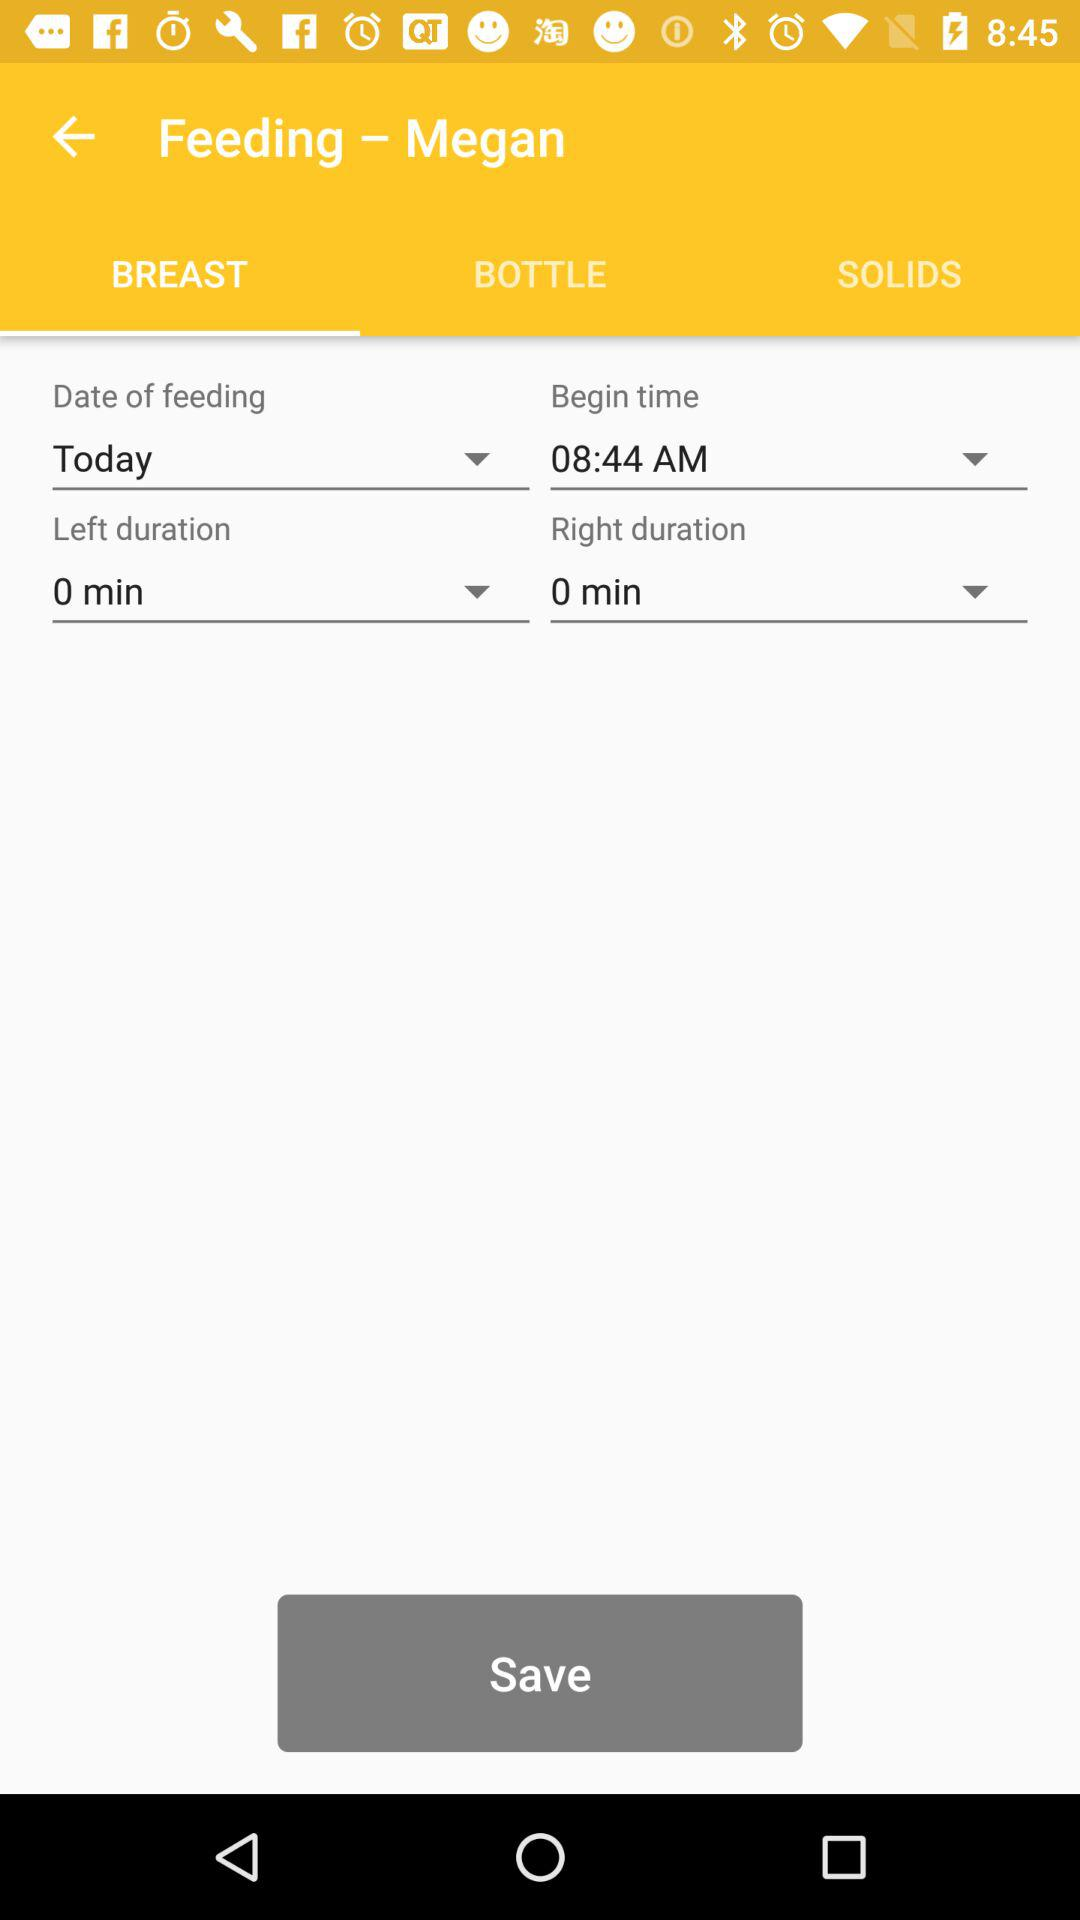What is the "left duration"? The "left duration" is 0 minutes. 